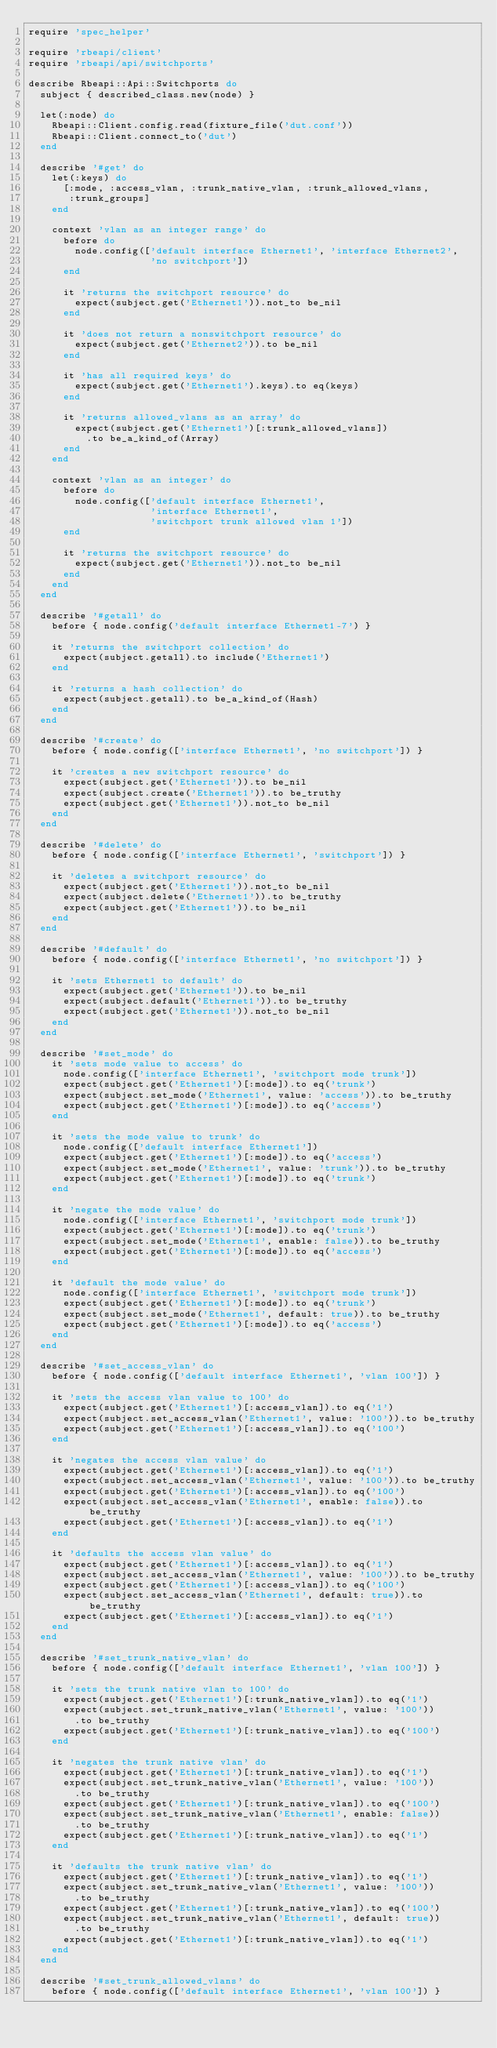Convert code to text. <code><loc_0><loc_0><loc_500><loc_500><_Ruby_>require 'spec_helper'

require 'rbeapi/client'
require 'rbeapi/api/switchports'

describe Rbeapi::Api::Switchports do
  subject { described_class.new(node) }

  let(:node) do
    Rbeapi::Client.config.read(fixture_file('dut.conf'))
    Rbeapi::Client.connect_to('dut')
  end

  describe '#get' do
    let(:keys) do
      [:mode, :access_vlan, :trunk_native_vlan, :trunk_allowed_vlans,
       :trunk_groups]
    end

    context 'vlan as an integer range' do
      before do
        node.config(['default interface Ethernet1', 'interface Ethernet2',
                     'no switchport'])
      end

      it 'returns the switchport resource' do
        expect(subject.get('Ethernet1')).not_to be_nil
      end

      it 'does not return a nonswitchport resource' do
        expect(subject.get('Ethernet2')).to be_nil
      end

      it 'has all required keys' do
        expect(subject.get('Ethernet1').keys).to eq(keys)
      end

      it 'returns allowed_vlans as an array' do
        expect(subject.get('Ethernet1')[:trunk_allowed_vlans])
          .to be_a_kind_of(Array)
      end
    end

    context 'vlan as an integer' do
      before do
        node.config(['default interface Ethernet1',
                     'interface Ethernet1',
                     'switchport trunk allowed vlan 1'])
      end

      it 'returns the switchport resource' do
        expect(subject.get('Ethernet1')).not_to be_nil
      end
    end
  end

  describe '#getall' do
    before { node.config('default interface Ethernet1-7') }

    it 'returns the switchport collection' do
      expect(subject.getall).to include('Ethernet1')
    end

    it 'returns a hash collection' do
      expect(subject.getall).to be_a_kind_of(Hash)
    end
  end

  describe '#create' do
    before { node.config(['interface Ethernet1', 'no switchport']) }

    it 'creates a new switchport resource' do
      expect(subject.get('Ethernet1')).to be_nil
      expect(subject.create('Ethernet1')).to be_truthy
      expect(subject.get('Ethernet1')).not_to be_nil
    end
  end

  describe '#delete' do
    before { node.config(['interface Ethernet1', 'switchport']) }

    it 'deletes a switchport resource' do
      expect(subject.get('Ethernet1')).not_to be_nil
      expect(subject.delete('Ethernet1')).to be_truthy
      expect(subject.get('Ethernet1')).to be_nil
    end
  end

  describe '#default' do
    before { node.config(['interface Ethernet1', 'no switchport']) }

    it 'sets Ethernet1 to default' do
      expect(subject.get('Ethernet1')).to be_nil
      expect(subject.default('Ethernet1')).to be_truthy
      expect(subject.get('Ethernet1')).not_to be_nil
    end
  end

  describe '#set_mode' do
    it 'sets mode value to access' do
      node.config(['interface Ethernet1', 'switchport mode trunk'])
      expect(subject.get('Ethernet1')[:mode]).to eq('trunk')
      expect(subject.set_mode('Ethernet1', value: 'access')).to be_truthy
      expect(subject.get('Ethernet1')[:mode]).to eq('access')
    end

    it 'sets the mode value to trunk' do
      node.config(['default interface Ethernet1'])
      expect(subject.get('Ethernet1')[:mode]).to eq('access')
      expect(subject.set_mode('Ethernet1', value: 'trunk')).to be_truthy
      expect(subject.get('Ethernet1')[:mode]).to eq('trunk')
    end

    it 'negate the mode value' do
      node.config(['interface Ethernet1', 'switchport mode trunk'])
      expect(subject.get('Ethernet1')[:mode]).to eq('trunk')
      expect(subject.set_mode('Ethernet1', enable: false)).to be_truthy
      expect(subject.get('Ethernet1')[:mode]).to eq('access')
    end

    it 'default the mode value' do
      node.config(['interface Ethernet1', 'switchport mode trunk'])
      expect(subject.get('Ethernet1')[:mode]).to eq('trunk')
      expect(subject.set_mode('Ethernet1', default: true)).to be_truthy
      expect(subject.get('Ethernet1')[:mode]).to eq('access')
    end
  end

  describe '#set_access_vlan' do
    before { node.config(['default interface Ethernet1', 'vlan 100']) }

    it 'sets the access vlan value to 100' do
      expect(subject.get('Ethernet1')[:access_vlan]).to eq('1')
      expect(subject.set_access_vlan('Ethernet1', value: '100')).to be_truthy
      expect(subject.get('Ethernet1')[:access_vlan]).to eq('100')
    end

    it 'negates the access vlan value' do
      expect(subject.get('Ethernet1')[:access_vlan]).to eq('1')
      expect(subject.set_access_vlan('Ethernet1', value: '100')).to be_truthy
      expect(subject.get('Ethernet1')[:access_vlan]).to eq('100')
      expect(subject.set_access_vlan('Ethernet1', enable: false)).to be_truthy
      expect(subject.get('Ethernet1')[:access_vlan]).to eq('1')
    end

    it 'defaults the access vlan value' do
      expect(subject.get('Ethernet1')[:access_vlan]).to eq('1')
      expect(subject.set_access_vlan('Ethernet1', value: '100')).to be_truthy
      expect(subject.get('Ethernet1')[:access_vlan]).to eq('100')
      expect(subject.set_access_vlan('Ethernet1', default: true)).to be_truthy
      expect(subject.get('Ethernet1')[:access_vlan]).to eq('1')
    end
  end

  describe '#set_trunk_native_vlan' do
    before { node.config(['default interface Ethernet1', 'vlan 100']) }

    it 'sets the trunk native vlan to 100' do
      expect(subject.get('Ethernet1')[:trunk_native_vlan]).to eq('1')
      expect(subject.set_trunk_native_vlan('Ethernet1', value: '100'))
        .to be_truthy
      expect(subject.get('Ethernet1')[:trunk_native_vlan]).to eq('100')
    end

    it 'negates the trunk native vlan' do
      expect(subject.get('Ethernet1')[:trunk_native_vlan]).to eq('1')
      expect(subject.set_trunk_native_vlan('Ethernet1', value: '100'))
        .to be_truthy
      expect(subject.get('Ethernet1')[:trunk_native_vlan]).to eq('100')
      expect(subject.set_trunk_native_vlan('Ethernet1', enable: false))
        .to be_truthy
      expect(subject.get('Ethernet1')[:trunk_native_vlan]).to eq('1')
    end

    it 'defaults the trunk native vlan' do
      expect(subject.get('Ethernet1')[:trunk_native_vlan]).to eq('1')
      expect(subject.set_trunk_native_vlan('Ethernet1', value: '100'))
        .to be_truthy
      expect(subject.get('Ethernet1')[:trunk_native_vlan]).to eq('100')
      expect(subject.set_trunk_native_vlan('Ethernet1', default: true))
        .to be_truthy
      expect(subject.get('Ethernet1')[:trunk_native_vlan]).to eq('1')
    end
  end

  describe '#set_trunk_allowed_vlans' do
    before { node.config(['default interface Ethernet1', 'vlan 100']) }
</code> 